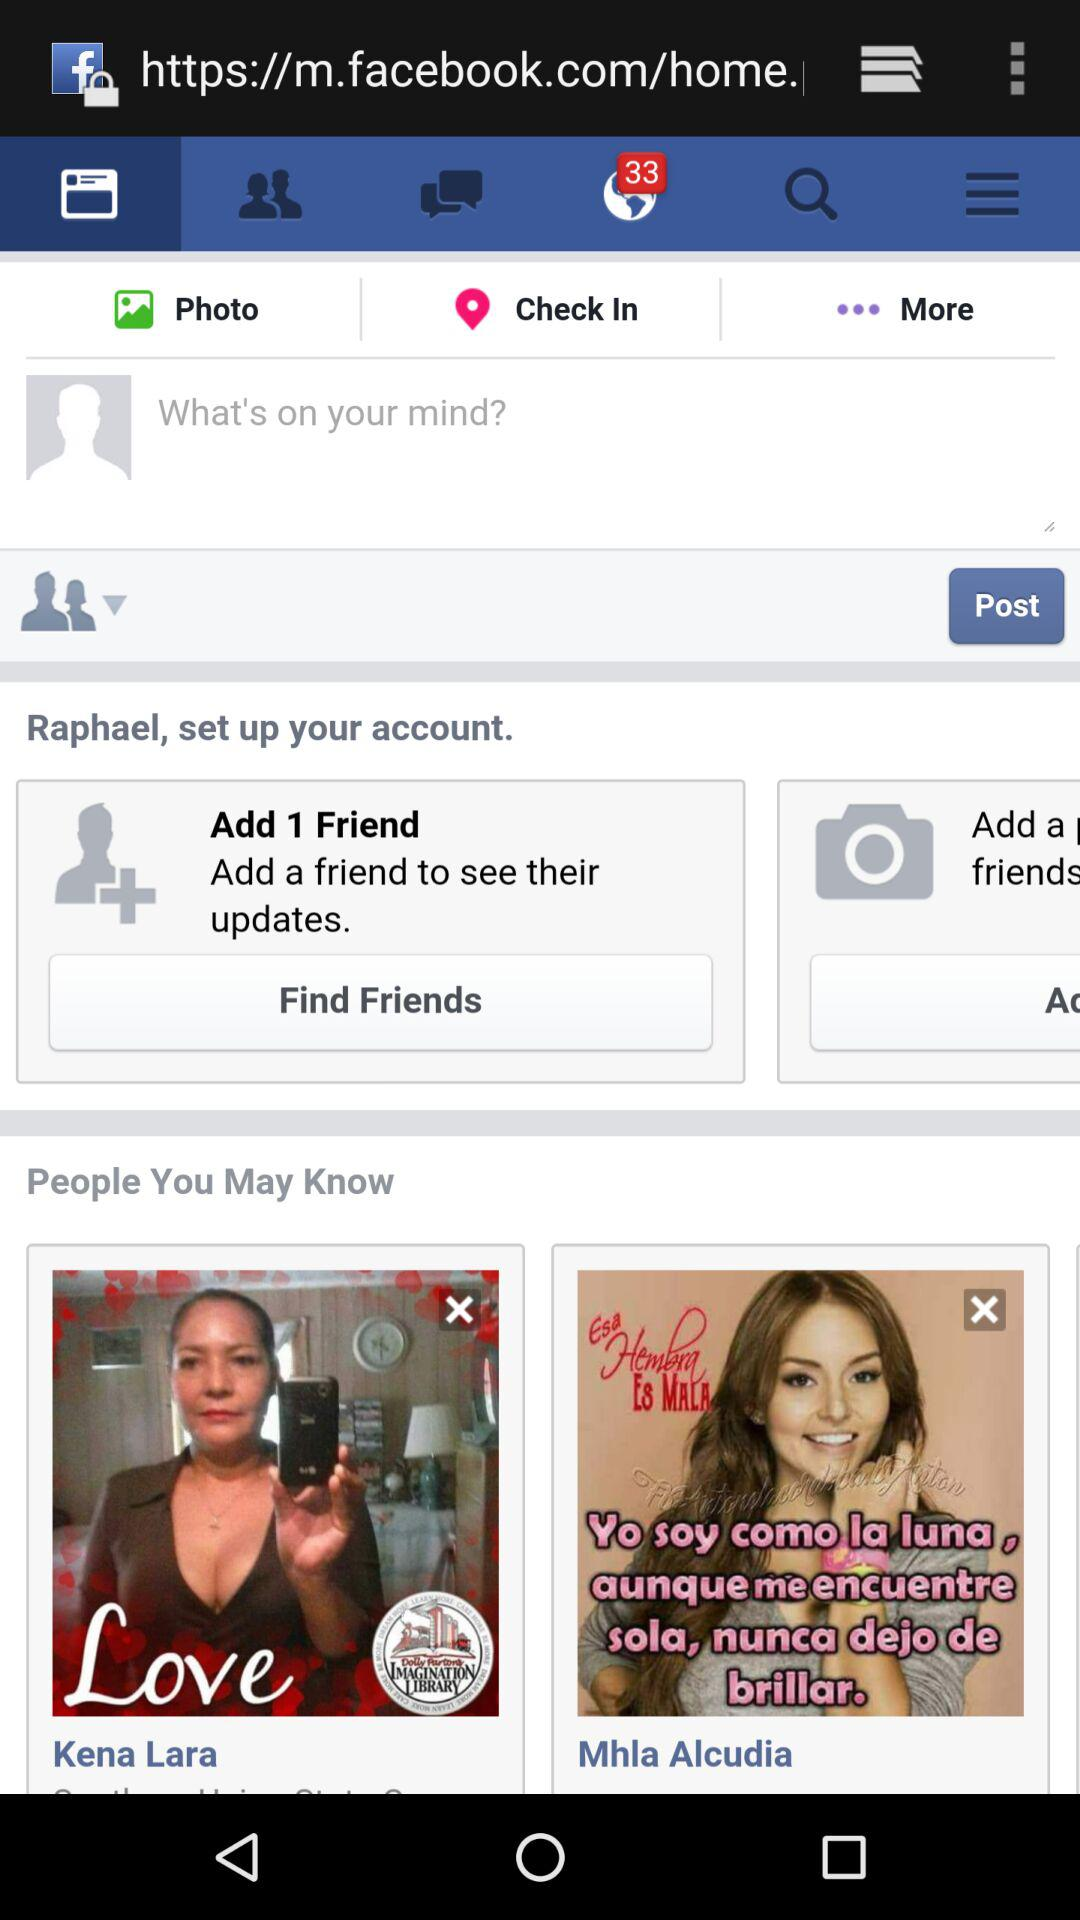What is the name of the person? The names of the people are Raphael, Kena Lara and Mhla Alcudia. 